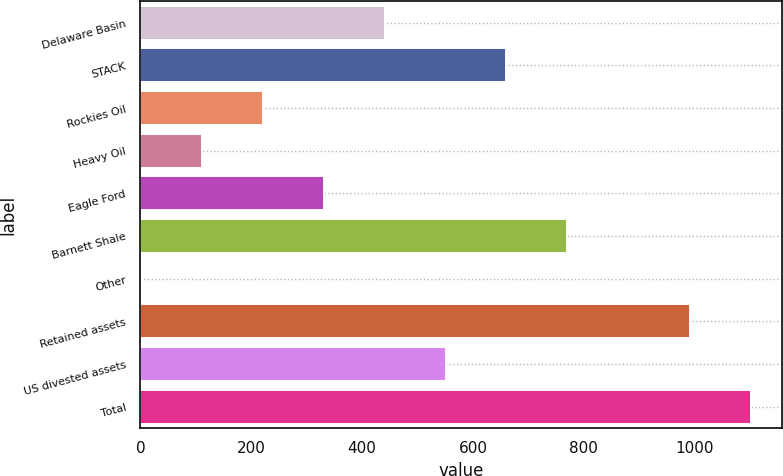Convert chart. <chart><loc_0><loc_0><loc_500><loc_500><bar_chart><fcel>Delaware Basin<fcel>STACK<fcel>Rockies Oil<fcel>Heavy Oil<fcel>Eagle Ford<fcel>Barnett Shale<fcel>Other<fcel>Retained assets<fcel>US divested assets<fcel>Total<nl><fcel>440.6<fcel>660.4<fcel>220.8<fcel>110.9<fcel>330.7<fcel>770.3<fcel>1<fcel>992<fcel>550.5<fcel>1101.9<nl></chart> 